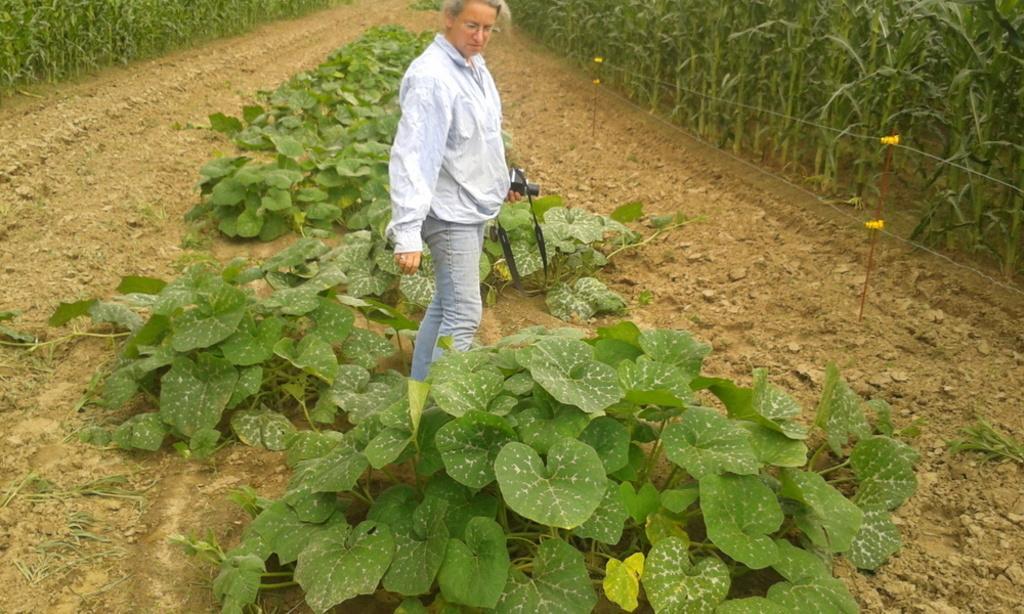Could you give a brief overview of what you see in this image? This person is standing and holding a camera. Here we can see plants. 